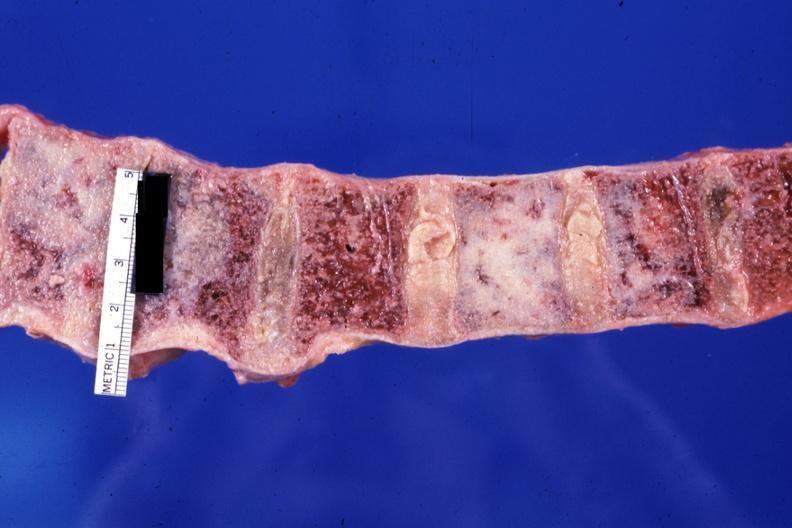what is present?
Answer the question using a single word or phrase. Joints 